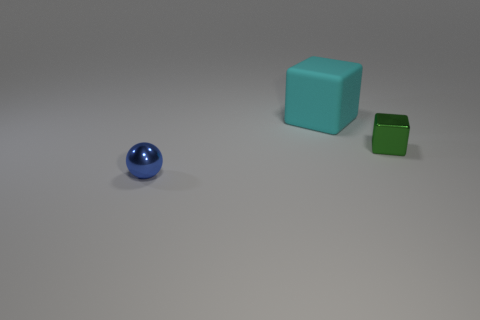Add 2 small green cubes. How many objects exist? 5 Subtract all cubes. How many objects are left? 1 Add 3 large yellow matte things. How many large yellow matte things exist? 3 Subtract 0 red cubes. How many objects are left? 3 Subtract all big red cylinders. Subtract all cyan matte objects. How many objects are left? 2 Add 1 green cubes. How many green cubes are left? 2 